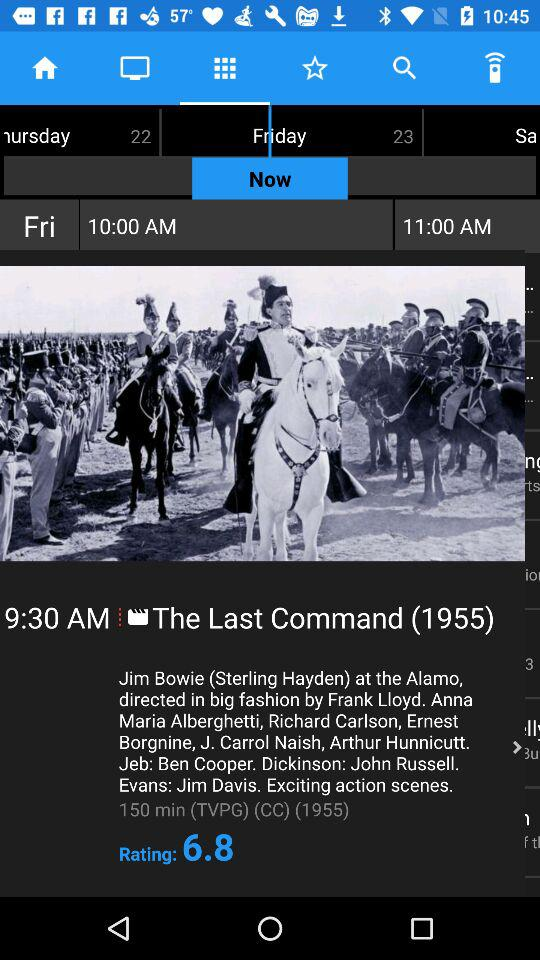What is the difference between the two displayed times?
Answer the question using a single word or phrase. 1 hour 